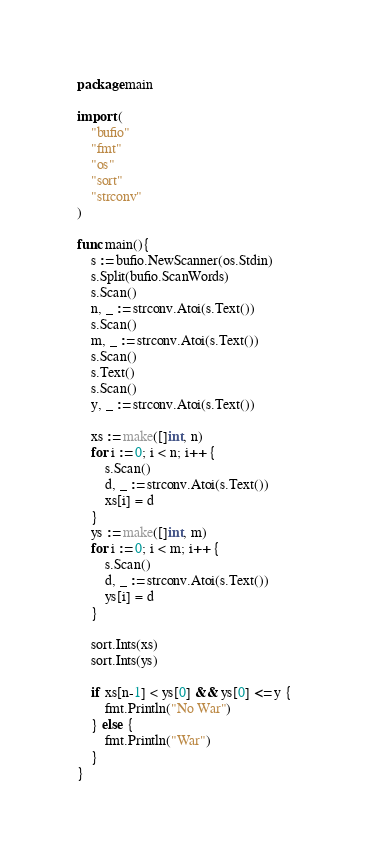Convert code to text. <code><loc_0><loc_0><loc_500><loc_500><_Go_>package main

import (
    "bufio"
    "fmt"
    "os"
    "sort"
    "strconv"
)    

func main(){
    s := bufio.NewScanner(os.Stdin)
    s.Split(bufio.ScanWords)
    s.Scan()
    n, _ := strconv.Atoi(s.Text())
    s.Scan()
    m, _ := strconv.Atoi(s.Text())
    s.Scan()
    s.Text()
    s.Scan()
    y, _ := strconv.Atoi(s.Text())
    
    xs := make([]int, n)
    for i := 0; i < n; i++ {
        s.Scan()
        d, _ := strconv.Atoi(s.Text())
        xs[i] = d
    }
    ys := make([]int, m)
    for i := 0; i < m; i++ {
        s.Scan()
        d, _ := strconv.Atoi(s.Text())
        ys[i] = d
    }
    
    sort.Ints(xs)
    sort.Ints(ys)
    
    if xs[n-1] < ys[0] && ys[0] <= y {
        fmt.Println("No War")
    } else {
        fmt.Println("War")
    }
}
</code> 